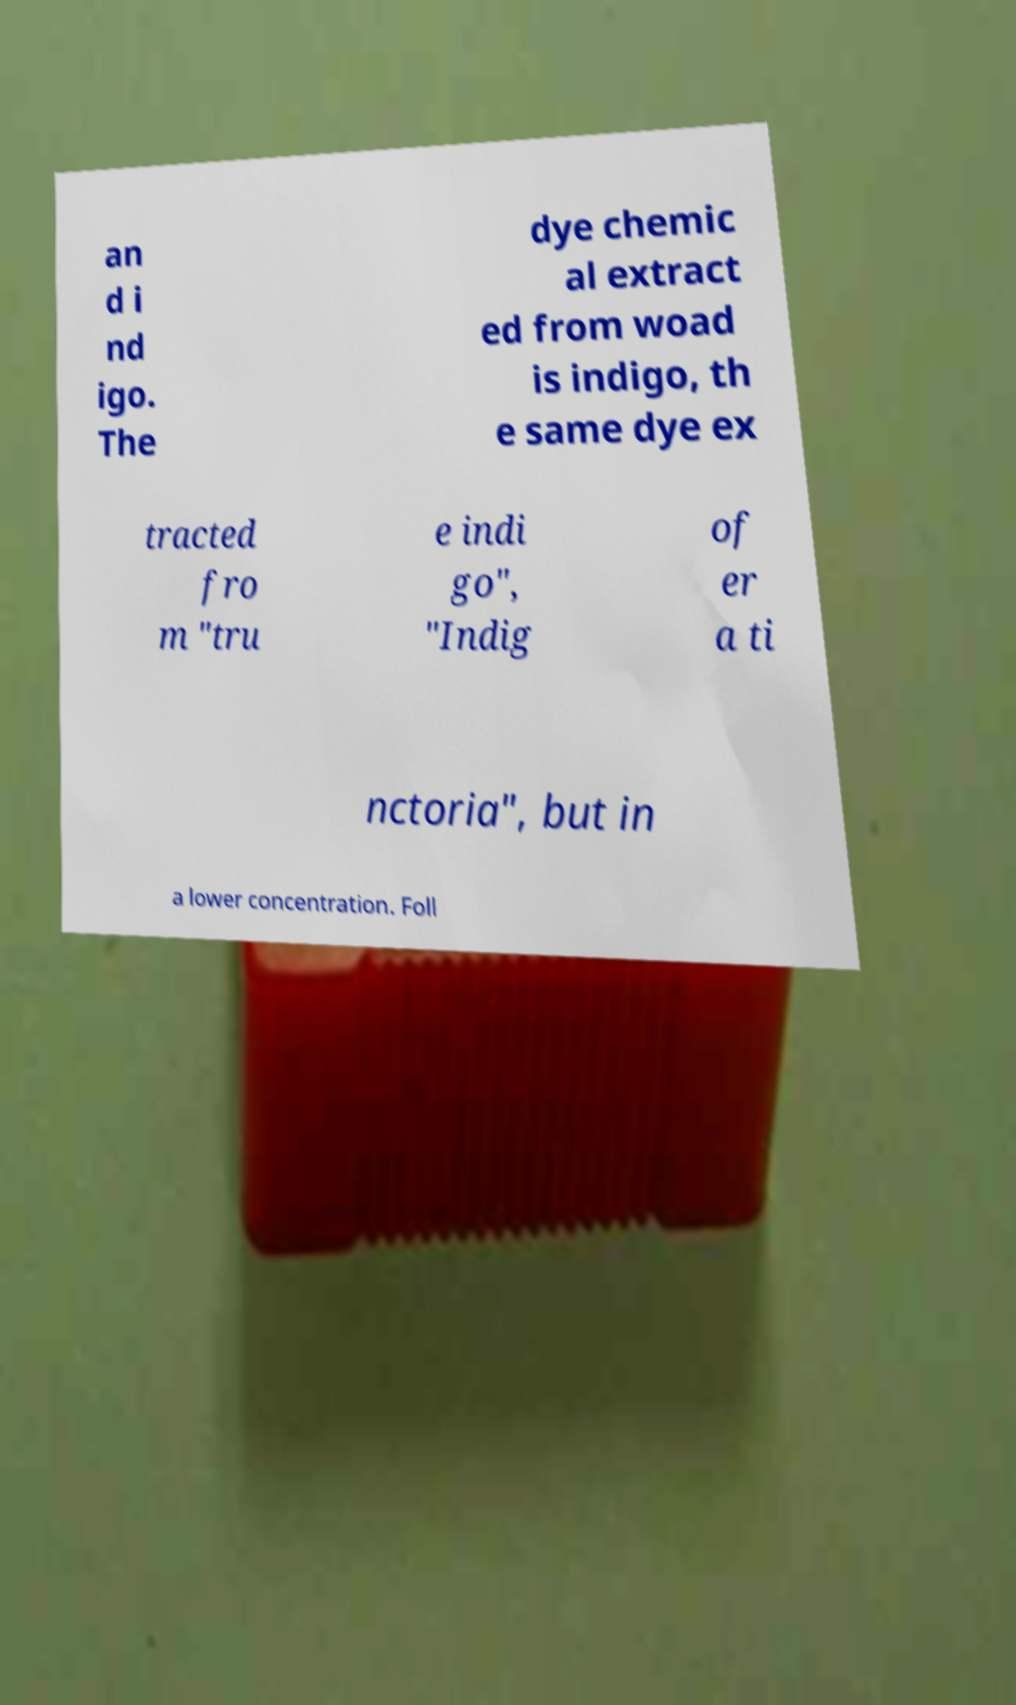Could you assist in decoding the text presented in this image and type it out clearly? an d i nd igo. The dye chemic al extract ed from woad is indigo, th e same dye ex tracted fro m "tru e indi go", "Indig of er a ti nctoria", but in a lower concentration. Foll 